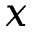Convert formula to latex. <formula><loc_0><loc_0><loc_500><loc_500>x</formula> 